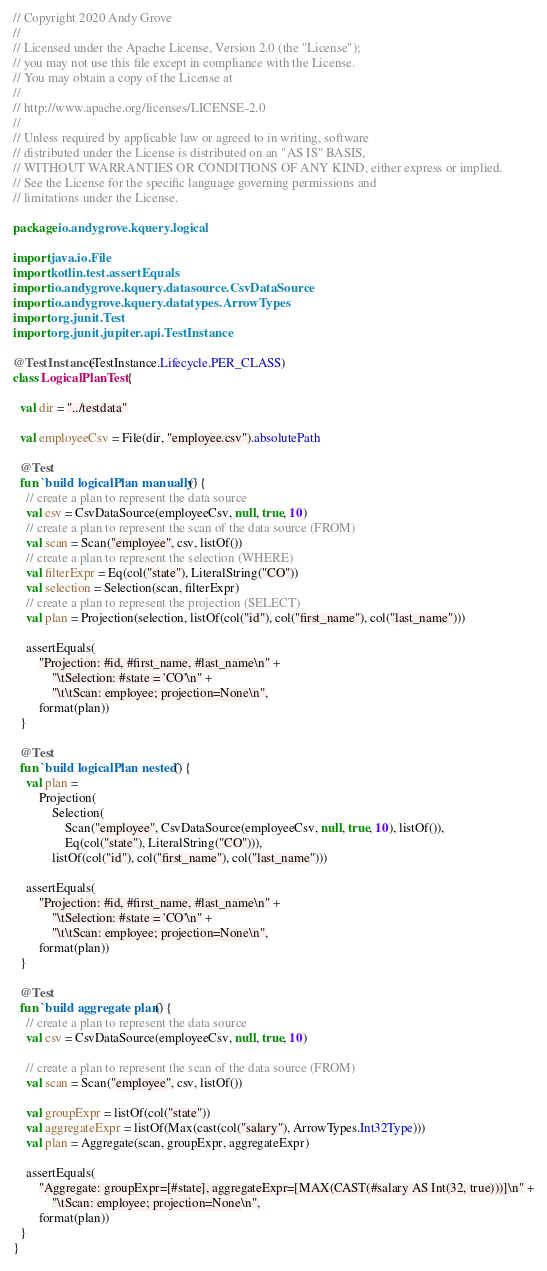Convert code to text. <code><loc_0><loc_0><loc_500><loc_500><_Kotlin_>// Copyright 2020 Andy Grove
//
// Licensed under the Apache License, Version 2.0 (the "License");
// you may not use this file except in compliance with the License.
// You may obtain a copy of the License at
//
// http://www.apache.org/licenses/LICENSE-2.0
//
// Unless required by applicable law or agreed to in writing, software
// distributed under the License is distributed on an "AS IS" BASIS,
// WITHOUT WARRANTIES OR CONDITIONS OF ANY KIND, either express or implied.
// See the License for the specific language governing permissions and
// limitations under the License.

package io.andygrove.kquery.logical

import java.io.File
import kotlin.test.assertEquals
import io.andygrove.kquery.datasource.CsvDataSource
import io.andygrove.kquery.datatypes.ArrowTypes
import org.junit.Test
import org.junit.jupiter.api.TestInstance

@TestInstance(TestInstance.Lifecycle.PER_CLASS)
class LogicalPlanTest {

  val dir = "../testdata"

  val employeeCsv = File(dir, "employee.csv").absolutePath

  @Test
  fun `build logicalPlan manually`() {
    // create a plan to represent the data source
    val csv = CsvDataSource(employeeCsv, null, true, 10)
    // create a plan to represent the scan of the data source (FROM)
    val scan = Scan("employee", csv, listOf())
    // create a plan to represent the selection (WHERE)
    val filterExpr = Eq(col("state"), LiteralString("CO"))
    val selection = Selection(scan, filterExpr)
    // create a plan to represent the projection (SELECT)
    val plan = Projection(selection, listOf(col("id"), col("first_name"), col("last_name")))

    assertEquals(
        "Projection: #id, #first_name, #last_name\n" +
            "\tSelection: #state = 'CO'\n" +
            "\t\tScan: employee; projection=None\n",
        format(plan))
  }

  @Test
  fun `build logicalPlan nested`() {
    val plan =
        Projection(
            Selection(
                Scan("employee", CsvDataSource(employeeCsv, null, true, 10), listOf()),
                Eq(col("state"), LiteralString("CO"))),
            listOf(col("id"), col("first_name"), col("last_name")))

    assertEquals(
        "Projection: #id, #first_name, #last_name\n" +
            "\tSelection: #state = 'CO'\n" +
            "\t\tScan: employee; projection=None\n",
        format(plan))
  }

  @Test
  fun `build aggregate plan`() {
    // create a plan to represent the data source
    val csv = CsvDataSource(employeeCsv, null, true, 10)

    // create a plan to represent the scan of the data source (FROM)
    val scan = Scan("employee", csv, listOf())

    val groupExpr = listOf(col("state"))
    val aggregateExpr = listOf(Max(cast(col("salary"), ArrowTypes.Int32Type)))
    val plan = Aggregate(scan, groupExpr, aggregateExpr)

    assertEquals(
        "Aggregate: groupExpr=[#state], aggregateExpr=[MAX(CAST(#salary AS Int(32, true)))]\n" +
            "\tScan: employee; projection=None\n",
        format(plan))
  }
}
</code> 